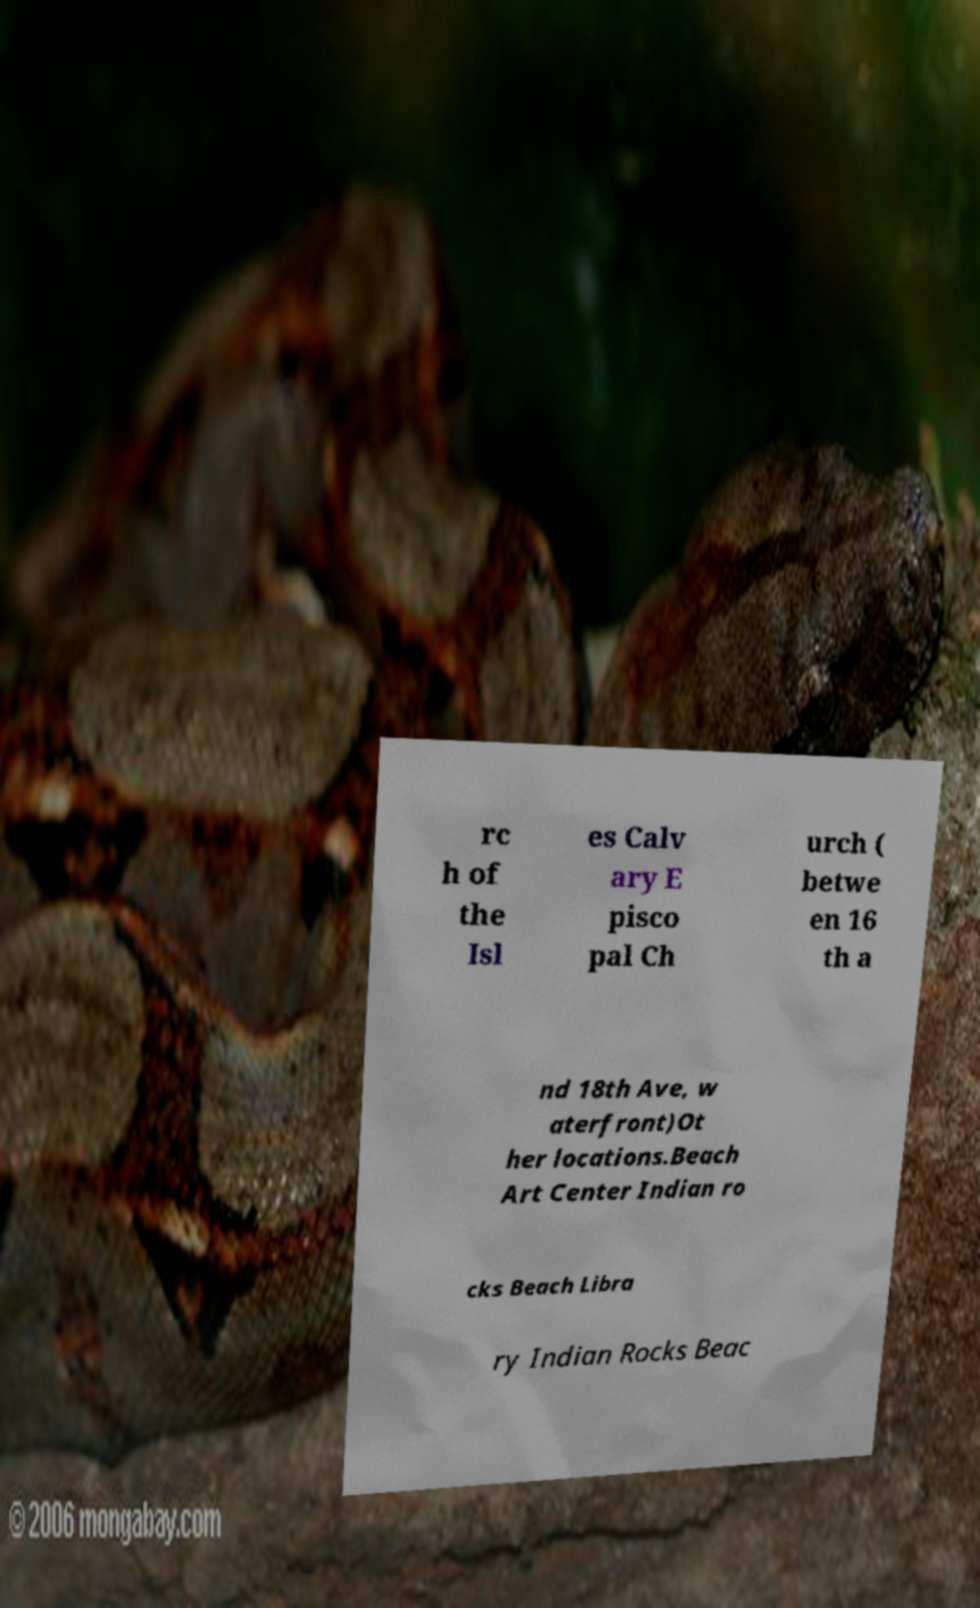Could you assist in decoding the text presented in this image and type it out clearly? rc h of the Isl es Calv ary E pisco pal Ch urch ( betwe en 16 th a nd 18th Ave, w aterfront)Ot her locations.Beach Art Center Indian ro cks Beach Libra ry Indian Rocks Beac 